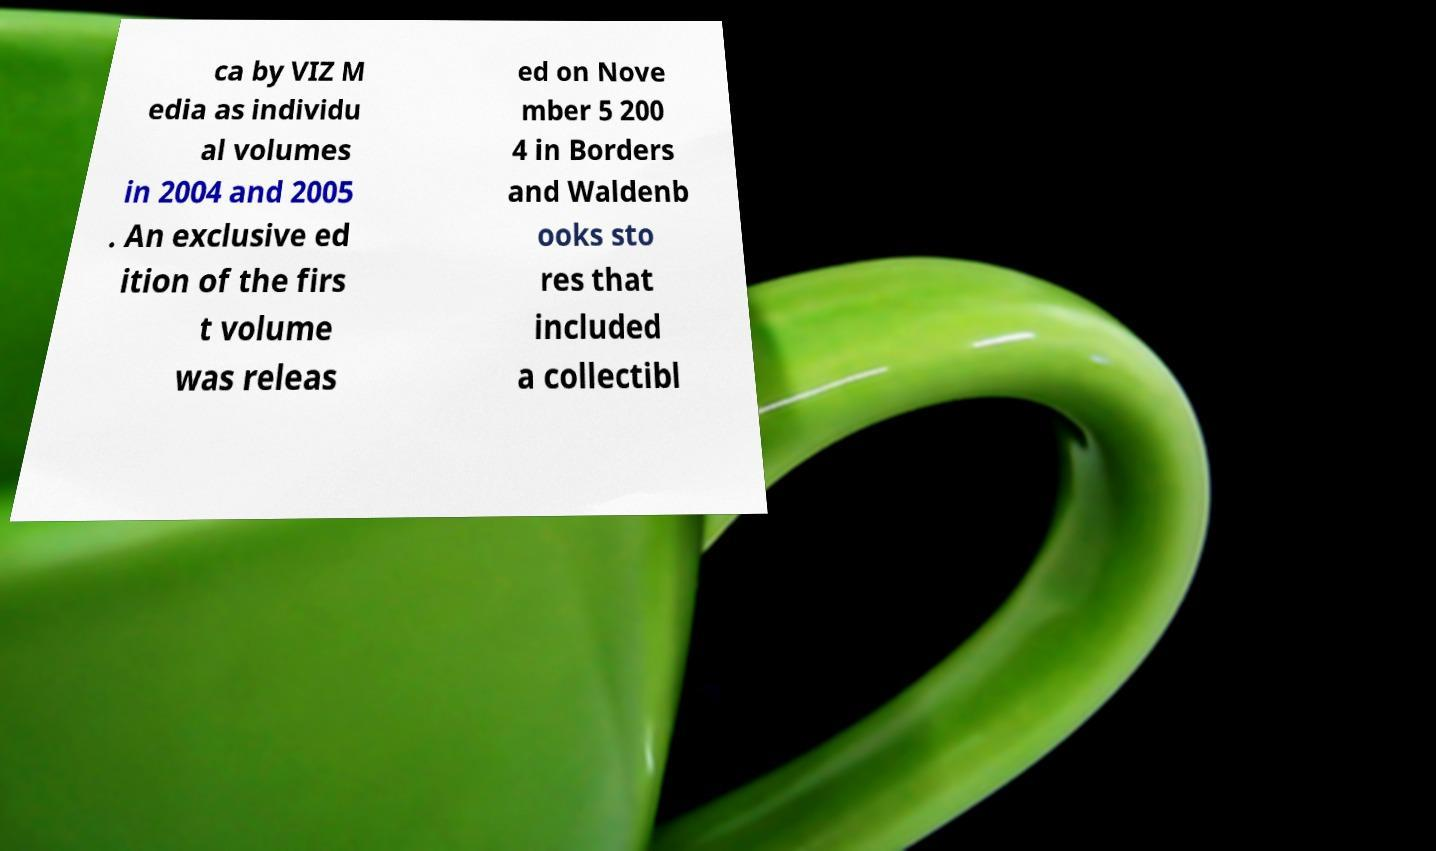I need the written content from this picture converted into text. Can you do that? ca by VIZ M edia as individu al volumes in 2004 and 2005 . An exclusive ed ition of the firs t volume was releas ed on Nove mber 5 200 4 in Borders and Waldenb ooks sto res that included a collectibl 